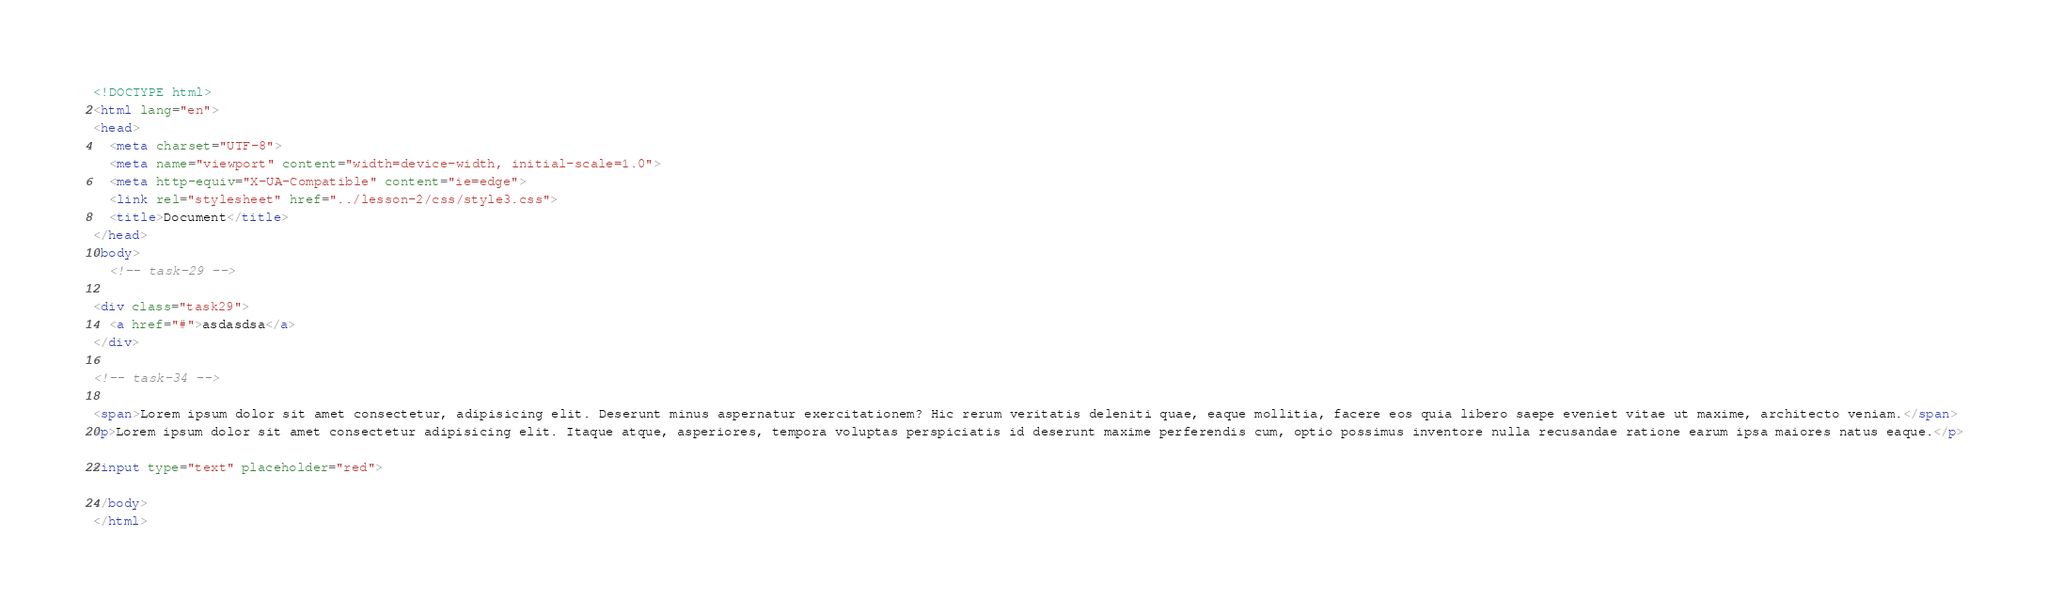Convert code to text. <code><loc_0><loc_0><loc_500><loc_500><_HTML_><!DOCTYPE html>
<html lang="en">
<head>
  <meta charset="UTF-8">
  <meta name="viewport" content="width=device-width, initial-scale=1.0">
  <meta http-equiv="X-UA-Compatible" content="ie=edge">
  <link rel="stylesheet" href="../lesson-2/css/style3.css">
  <title>Document</title>
</head>
<body>
  <!-- task-29 -->

<div class="task29">
  <a href="#">asdasdsa</a>
</div>

<!-- task-34 -->

<span>Lorem ipsum dolor sit amet consectetur, adipisicing elit. Deserunt minus aspernatur exercitationem? Hic rerum veritatis deleniti quae, eaque mollitia, facere eos quia libero saepe eveniet vitae ut maxime, architecto veniam.</span>
<p>Lorem ipsum dolor sit amet consectetur adipisicing elit. Itaque atque, asperiores, tempora voluptas perspiciatis id deserunt maxime perferendis cum, optio possimus inventore nulla recusandae ratione earum ipsa maiores natus eaque.</p>

<input type="text" placeholder="red">

</body>
</html></code> 